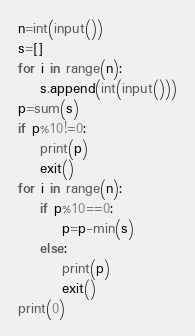<code> <loc_0><loc_0><loc_500><loc_500><_Python_>n=int(input())
s=[]
for i in range(n):
    s.append(int(input()))
p=sum(s)
if p%10!=0:
    print(p)
    exit()
for i in range(n):
    if p%10==0:
        p=p-min(s)
    else:
        print(p)
        exit()
print(0)</code> 